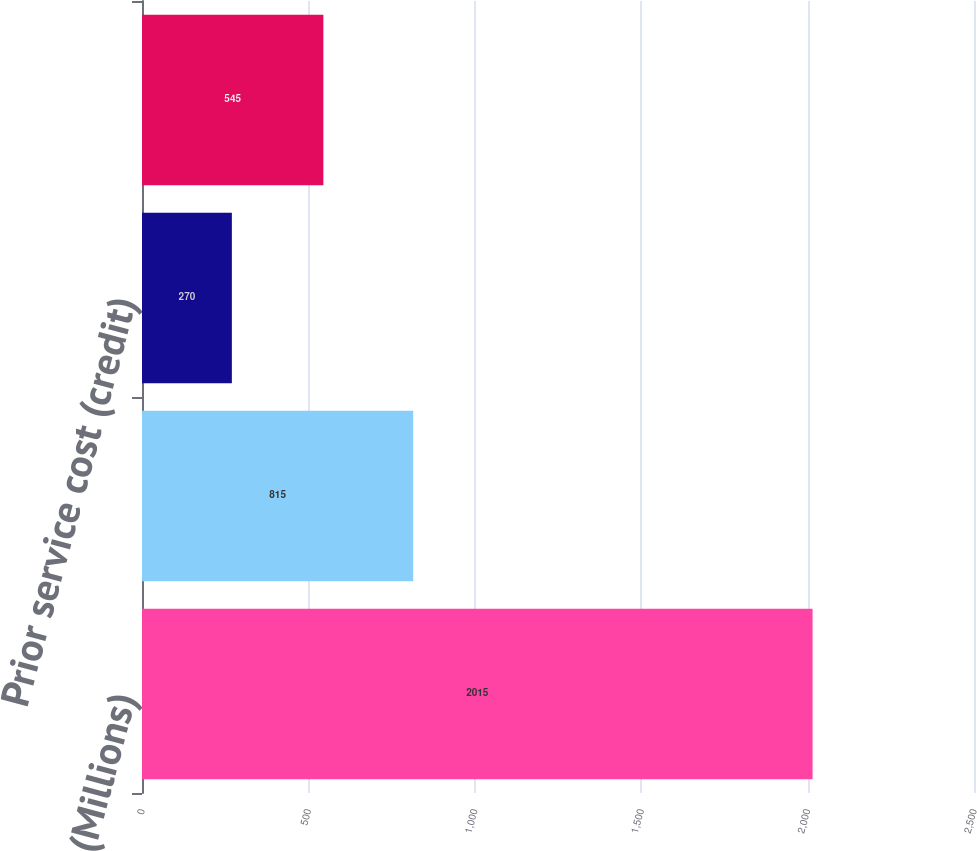Convert chart to OTSL. <chart><loc_0><loc_0><loc_500><loc_500><bar_chart><fcel>(Millions)<fcel>Net actuarial loss (gain)<fcel>Prior service cost (credit)<fcel>Ending balance<nl><fcel>2015<fcel>815<fcel>270<fcel>545<nl></chart> 